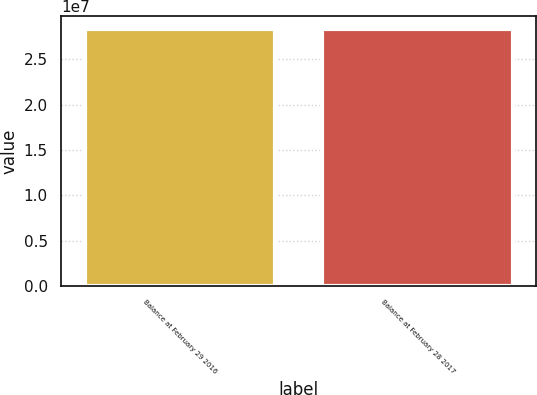Convert chart to OTSL. <chart><loc_0><loc_0><loc_500><loc_500><bar_chart><fcel>Balance at February 29 2016<fcel>Balance at February 28 2017<nl><fcel>2.83585e+07<fcel>2.83585e+07<nl></chart> 